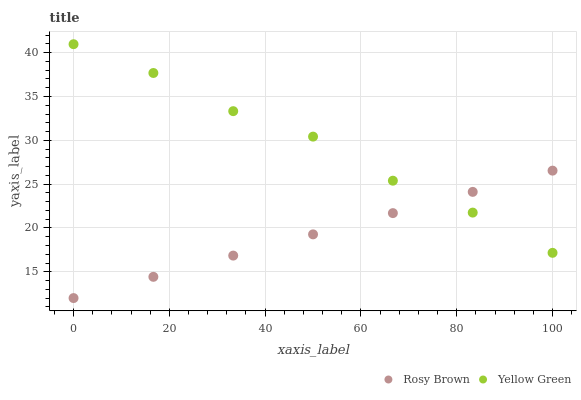Does Rosy Brown have the minimum area under the curve?
Answer yes or no. Yes. Does Yellow Green have the maximum area under the curve?
Answer yes or no. Yes. Does Yellow Green have the minimum area under the curve?
Answer yes or no. No. Is Rosy Brown the smoothest?
Answer yes or no. Yes. Is Yellow Green the roughest?
Answer yes or no. Yes. Is Yellow Green the smoothest?
Answer yes or no. No. Does Rosy Brown have the lowest value?
Answer yes or no. Yes. Does Yellow Green have the lowest value?
Answer yes or no. No. Does Yellow Green have the highest value?
Answer yes or no. Yes. Does Yellow Green intersect Rosy Brown?
Answer yes or no. Yes. Is Yellow Green less than Rosy Brown?
Answer yes or no. No. Is Yellow Green greater than Rosy Brown?
Answer yes or no. No. 